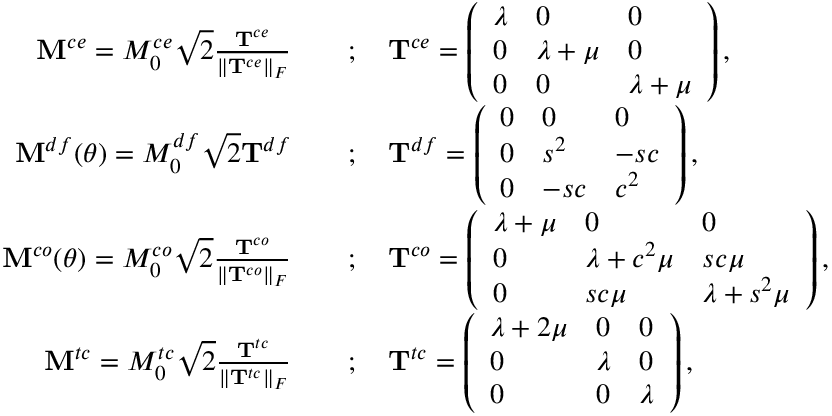<formula> <loc_0><loc_0><loc_500><loc_500>\begin{array} { r l } { { M } ^ { c e } = M _ { 0 } ^ { c e } \sqrt { 2 } \frac { T ^ { c e } } { \| T ^ { c e } \| _ { F } } \quad } & { ; \quad T ^ { c e } = \left ( \begin{array} { l l l } { \lambda } & { 0 } & { 0 } \\ { 0 } & { \lambda + \mu } & { 0 } \\ { 0 } & { 0 } & { \lambda + \mu } \end{array} \right ) , } \\ { { M } ^ { d f } ( \theta ) = M _ { 0 } ^ { d f } \sqrt { 2 } T ^ { d f } \quad } & { ; \quad T ^ { d f } = \left ( \begin{array} { l l l } { 0 } & { 0 } & { 0 } \\ { 0 } & { s ^ { 2 } } & { - s c } \\ { 0 } & { - s c } & { c ^ { 2 } } \end{array} \right ) , } \\ { { M } ^ { c o } ( \theta ) = M _ { 0 } ^ { c o } \sqrt { 2 } \frac { T ^ { c o } } { \| T ^ { c o } \| _ { F } } \quad } & { ; \quad T ^ { c o } = \left ( \begin{array} { l l l } { \lambda + \mu } & { 0 } & { 0 } \\ { 0 } & { \lambda + c ^ { 2 } \mu } & { s c \mu } \\ { 0 } & { s c \mu } & { \lambda + s ^ { 2 } \mu } \end{array} \right ) , } \\ { { M } ^ { t c } = M _ { 0 } ^ { t c } \sqrt { 2 } \frac { T ^ { t c } } { \| T ^ { t c } \| _ { F } } \quad } & { ; \quad T ^ { t c } = \left ( \begin{array} { l l l } { \lambda + 2 \mu } & { 0 } & { 0 } \\ { 0 } & { \lambda } & { 0 } \\ { 0 } & { 0 } & { \lambda } \end{array} \right ) , } \end{array}</formula> 